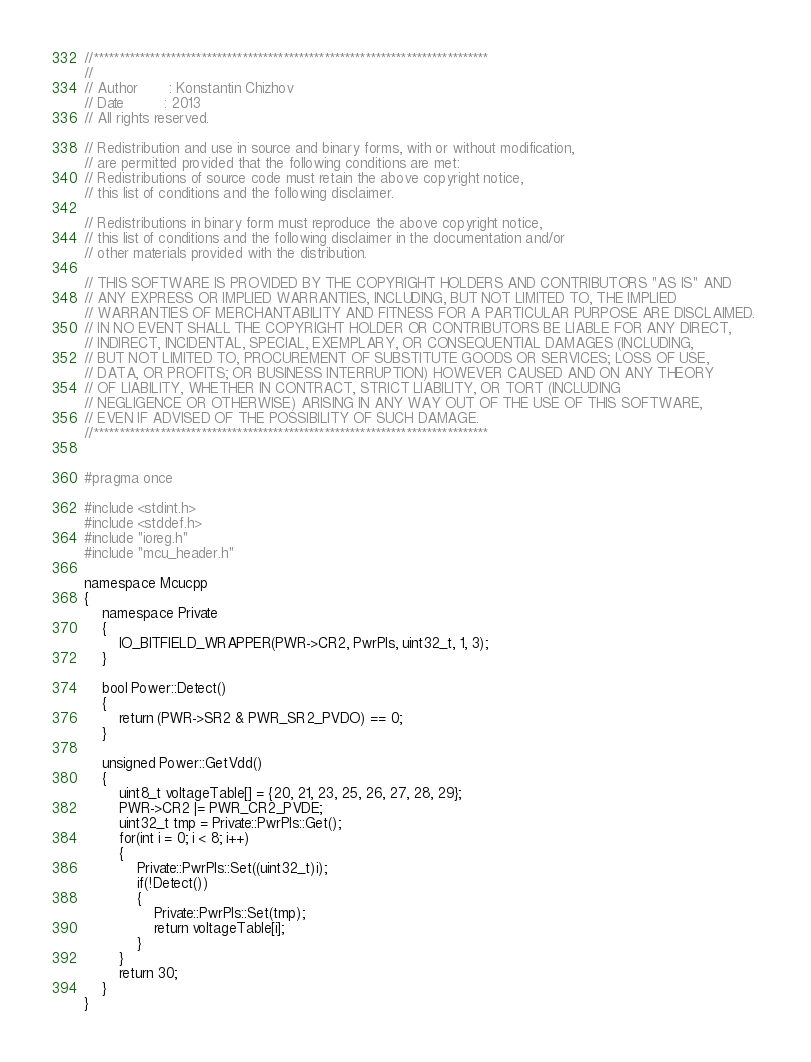<code> <loc_0><loc_0><loc_500><loc_500><_C_>//*****************************************************************************
//
// Author		: Konstantin Chizhov
// Date			: 2013
// All rights reserved.

// Redistribution and use in source and binary forms, with or without modification, 
// are permitted provided that the following conditions are met:
// Redistributions of source code must retain the above copyright notice, 
// this list of conditions and the following disclaimer.

// Redistributions in binary form must reproduce the above copyright notice, 
// this list of conditions and the following disclaimer in the documentation and/or 
// other materials provided with the distribution.

// THIS SOFTWARE IS PROVIDED BY THE COPYRIGHT HOLDERS AND CONTRIBUTORS "AS IS" AND 
// ANY EXPRESS OR IMPLIED WARRANTIES, INCLUDING, BUT NOT LIMITED TO, THE IMPLIED 
// WARRANTIES OF MERCHANTABILITY AND FITNESS FOR A PARTICULAR PURPOSE ARE DISCLAIMED. 
// IN NO EVENT SHALL THE COPYRIGHT HOLDER OR CONTRIBUTORS BE LIABLE FOR ANY DIRECT, 
// INDIRECT, INCIDENTAL, SPECIAL, EXEMPLARY, OR CONSEQUENTIAL DAMAGES (INCLUDING, 
// BUT NOT LIMITED TO, PROCUREMENT OF SUBSTITUTE GOODS OR SERVICES; LOSS OF USE, 
// DATA, OR PROFITS; OR BUSINESS INTERRUPTION) HOWEVER CAUSED AND ON ANY THEORY 
// OF LIABILITY, WHETHER IN CONTRACT, STRICT LIABILITY, OR TORT (INCLUDING 
// NEGLIGENCE OR OTHERWISE) ARISING IN ANY WAY OUT OF THE USE OF THIS SOFTWARE, 
// EVEN IF ADVISED OF THE POSSIBILITY OF SUCH DAMAGE.
//*****************************************************************************


#pragma once

#include <stdint.h>
#include <stddef.h>
#include "ioreg.h"
#include "mcu_header.h"

namespace Mcucpp
{
	namespace Private
	{
		IO_BITFIELD_WRAPPER(PWR->CR2, PwrPls, uint32_t, 1, 3);
	}
	
	bool Power::Detect()
	{
		return (PWR->SR2 & PWR_SR2_PVDO) == 0;
	}
	
	unsigned Power::GetVdd()
	{
		uint8_t voltageTable[] = {20, 21, 23, 25, 26, 27, 28, 29};
		PWR->CR2 |= PWR_CR2_PVDE;
		uint32_t tmp = Private::PwrPls::Get();
		for(int i = 0; i < 8; i++)
		{
			Private::PwrPls::Set((uint32_t)i);
			if(!Detect())
			{
				Private::PwrPls::Set(tmp);
				return voltageTable[i];
			}
		}
		return 30;
	}
}
</code> 